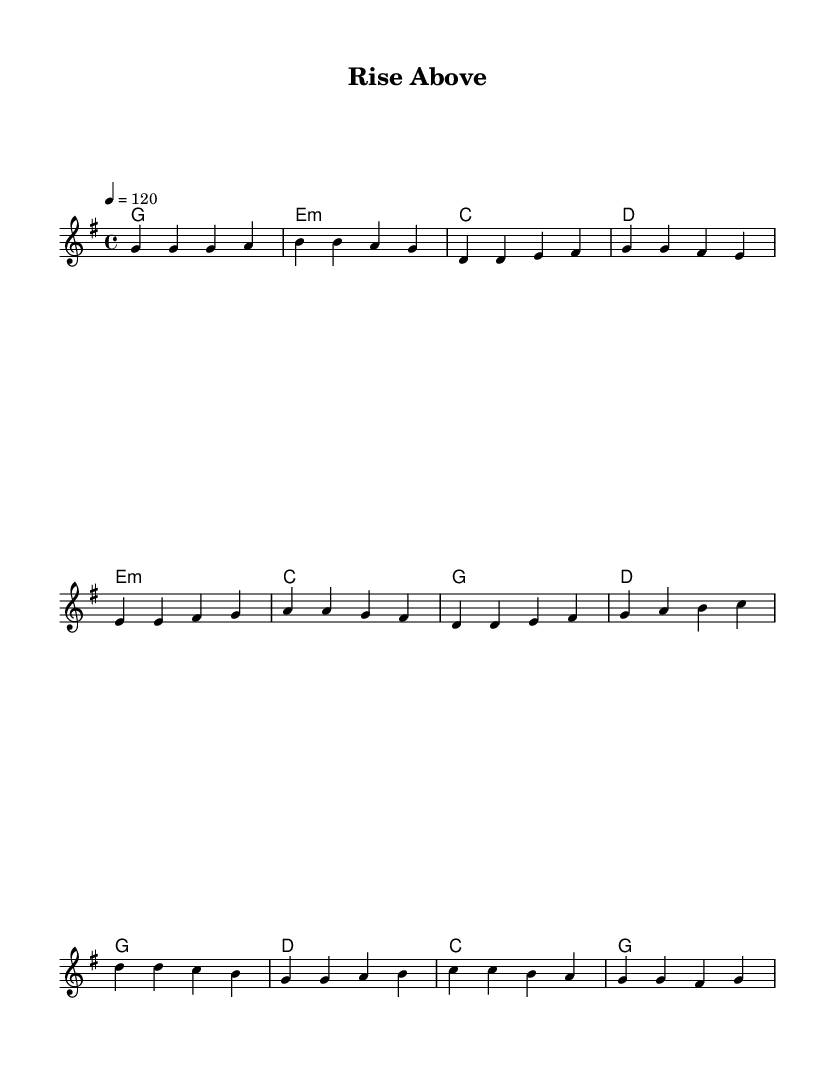What is the key signature of this music? The key signature is G major, which has one sharp (F#).
Answer: G major What is the time signature? The time signature is 4/4, indicating four beats per measure.
Answer: 4/4 What is the tempo marking for the piece? The tempo marking indicates a pace of 120 beats per minute.
Answer: 120 How many measures are in the verse section? The verse section consists of four measures, identifiable by counting the corresponding segments.
Answer: 4 Identify the first chord in the verse section. The first chord in the verse section is G major, as listed in the chord symbols at the beginning of the line.
Answer: G What is the last note of the chorus? The last note of the chorus is G, found at the end of the melody line in the score.
Answer: G What does the song title suggest about its content? The title "Rise Above" indicates themes of overcoming adversity, reflective of positive pop lyrics.
Answer: Overcoming challenges 